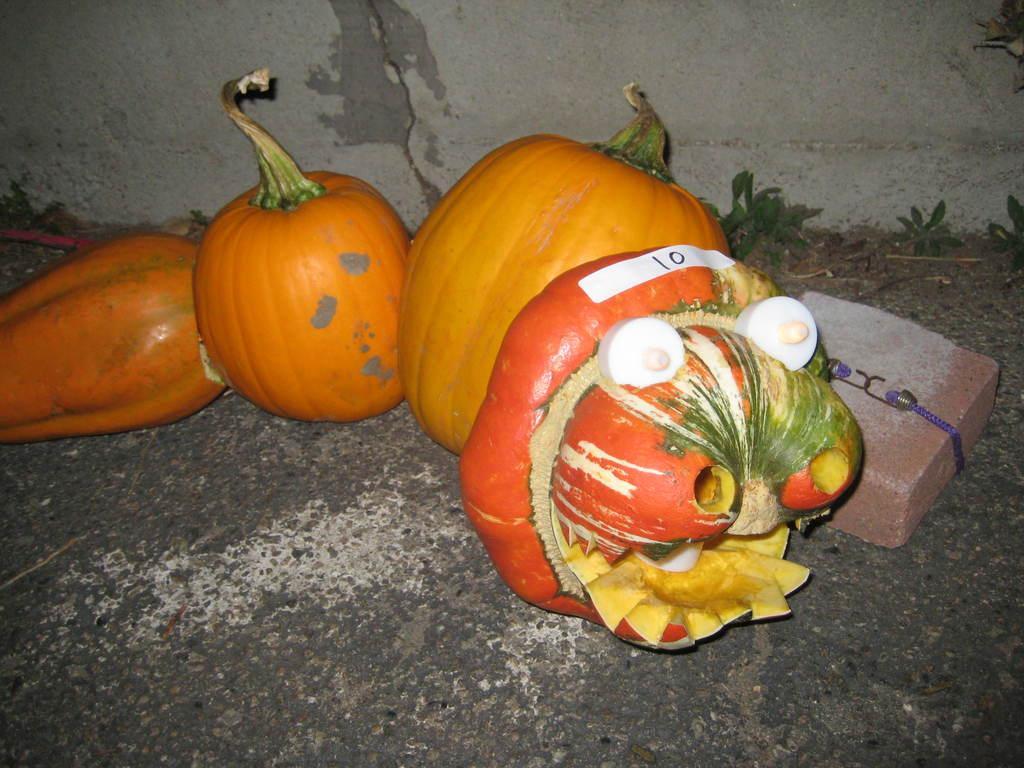Describe this image in one or two sentences. This image consists of pumpkins. At the bottom, there is a road. On the right, it looks like a brick. In the background, there is a wall. 